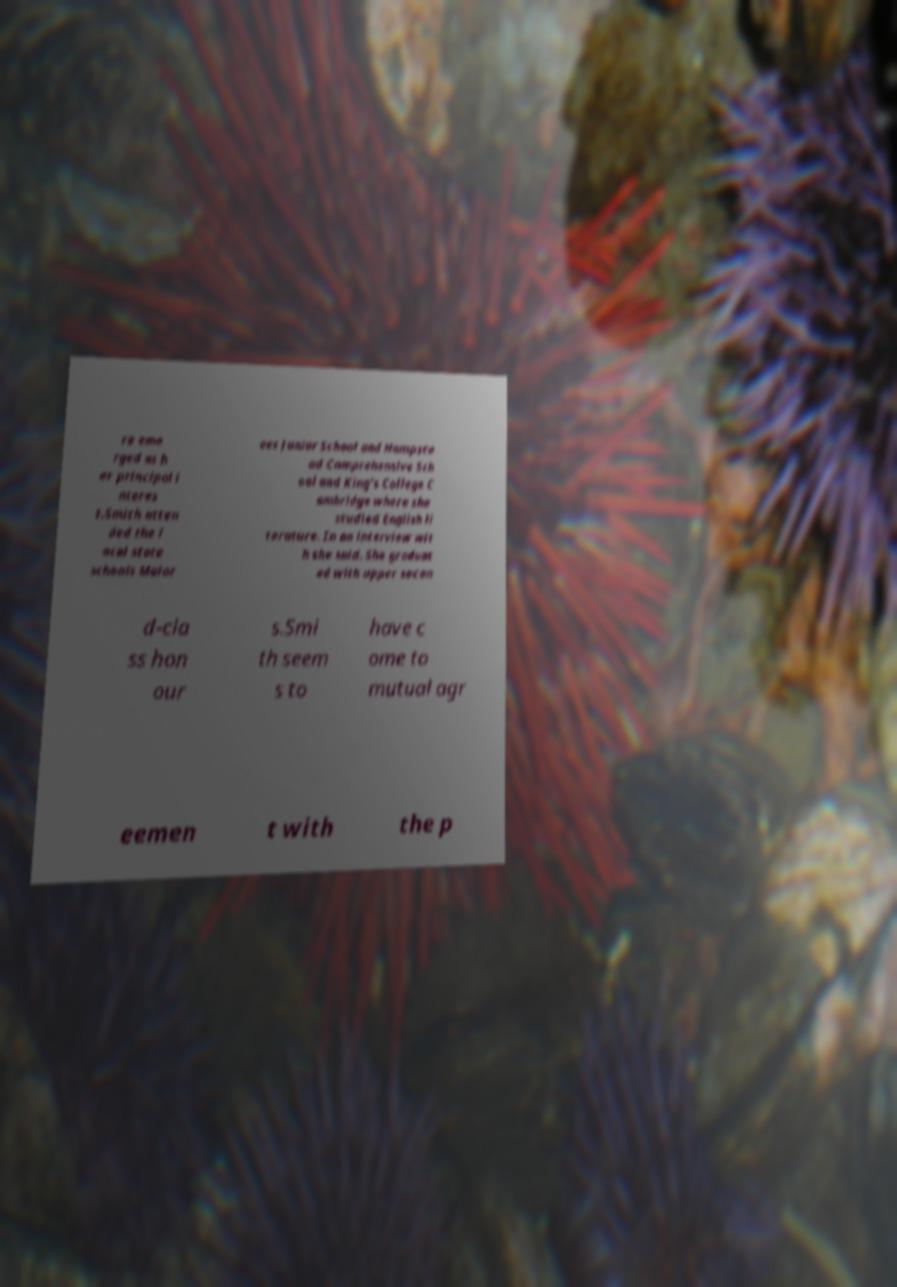Can you read and provide the text displayed in the image?This photo seems to have some interesting text. Can you extract and type it out for me? re eme rged as h er principal i nteres t.Smith atten ded the l ocal state schools Malor ees Junior School and Hampste ad Comprehensive Sch ool and King's College C ambridge where she studied English li terature. In an interview wit h she said. She graduat ed with upper secon d-cla ss hon our s.Smi th seem s to have c ome to mutual agr eemen t with the p 